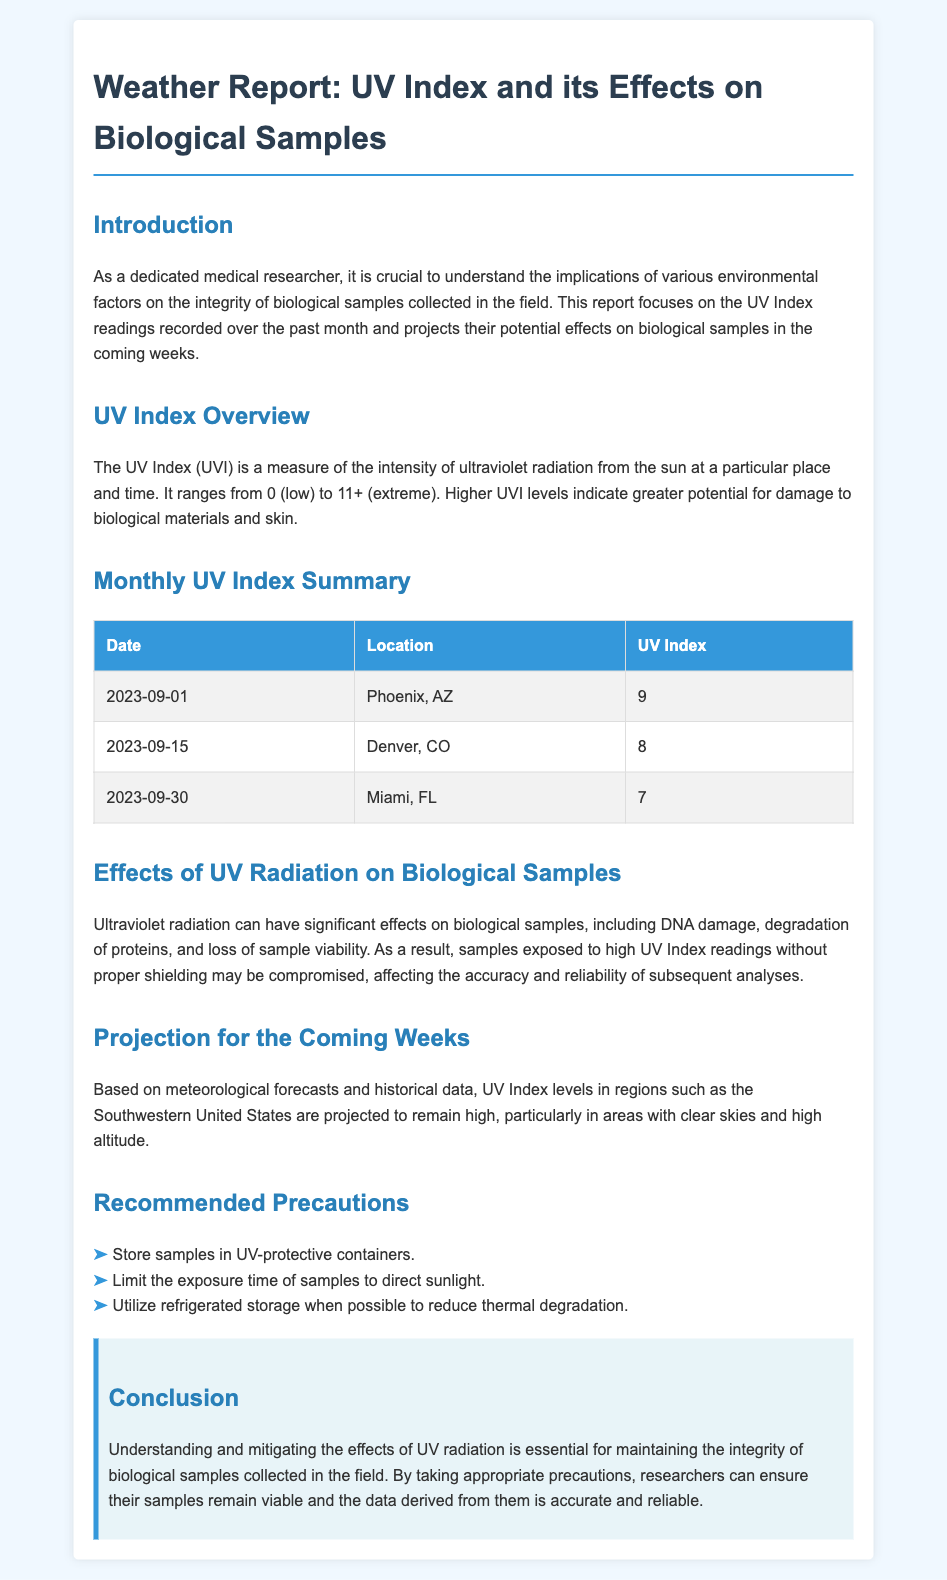What was the UV Index in Phoenix, AZ on 2023-09-01? The document specifies that the UV Index in Phoenix, AZ on this date was 9.
Answer: 9 What is the highest UV Index recorded in the summary? The highest UV Index recorded in the table is highlighted, which is 9 in Phoenix, AZ.
Answer: 9 How many locations are listed in the monthly UV Index summary? The summary contains a total of three entries corresponding to different locations.
Answer: 3 What one effect of UV radiation on biological samples is mentioned? The document states various effects, but one key effect mentioned is DNA damage.
Answer: DNA damage Which two precautions are recommended for protecting biological samples? Two specific precautions highlighted in the document are to use UV-protective containers and limit exposure to sunlight.
Answer: UV-protective containers and limit exposure to sunlight What does UVI stand for? The document defines UVI as an abbreviation for the UV Index.
Answer: UV Index In which regions is the UV Index projected to remain high? The document indicates that the Southwestern United States is projected to have high UV Index levels.
Answer: Southwestern United States What date marks the end of the month covered in the summary? The summary includes readings up to September 30, 2023.
Answer: 2023-09-30 What is the effect of UV exposure according to the document? The document notes that exposure can lead to loss of sample viability.
Answer: Loss of sample viability 